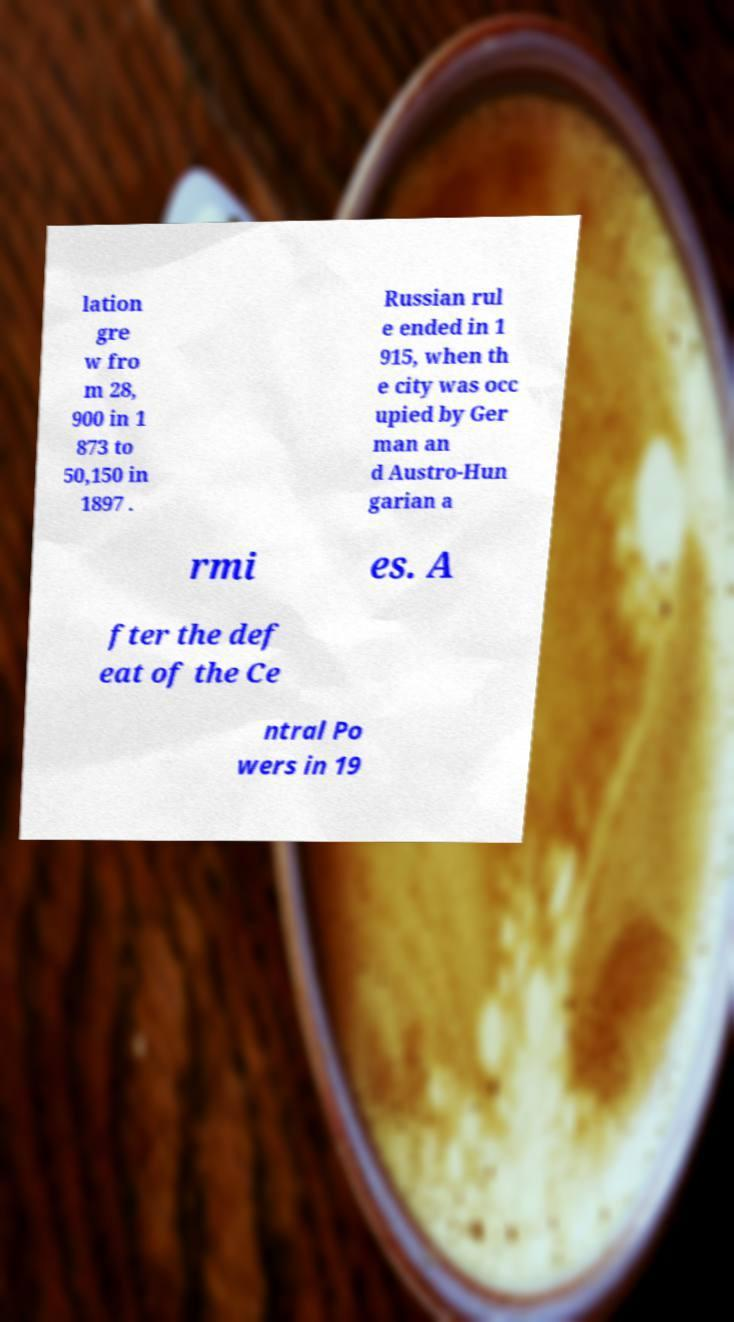Could you assist in decoding the text presented in this image and type it out clearly? lation gre w fro m 28, 900 in 1 873 to 50,150 in 1897 . Russian rul e ended in 1 915, when th e city was occ upied by Ger man an d Austro-Hun garian a rmi es. A fter the def eat of the Ce ntral Po wers in 19 